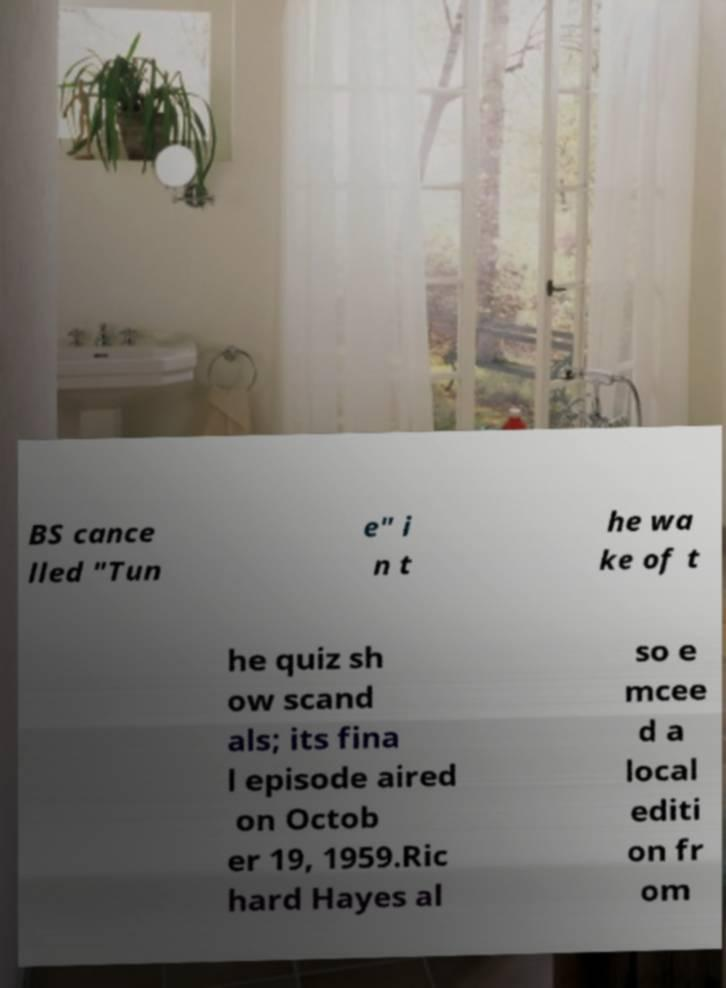There's text embedded in this image that I need extracted. Can you transcribe it verbatim? BS cance lled "Tun e" i n t he wa ke of t he quiz sh ow scand als; its fina l episode aired on Octob er 19, 1959.Ric hard Hayes al so e mcee d a local editi on fr om 